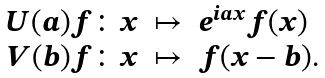Convert formula to latex. <formula><loc_0><loc_0><loc_500><loc_500>\begin{array} { r c l } U ( a ) f \colon x & \mapsto & e ^ { i a x } f ( x ) \\ V ( b ) f \colon x & \mapsto & f ( x - b ) . \end{array}</formula> 